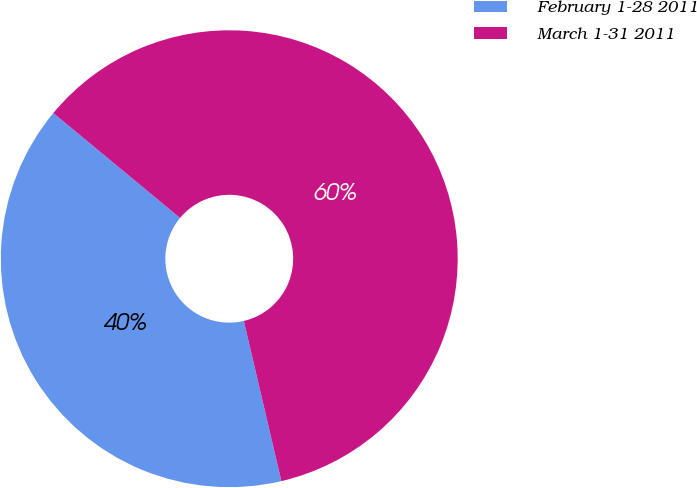Convert chart. <chart><loc_0><loc_0><loc_500><loc_500><pie_chart><fcel>February 1-28 2011<fcel>March 1-31 2011<nl><fcel>39.67%<fcel>60.33%<nl></chart> 